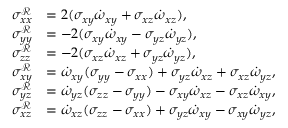Convert formula to latex. <formula><loc_0><loc_0><loc_500><loc_500>\begin{array} { r l } { \sigma _ { x x } ^ { \mathcal { R } } } & { = 2 ( \sigma _ { x y } \dot { \omega } _ { x y } + \sigma _ { x z } \dot { \omega } _ { x z } ) , } \\ { \sigma _ { y y } ^ { \mathcal { R } } } & { = - 2 ( \sigma _ { x y } \dot { \omega } _ { x y } - \sigma _ { y z } \dot { \omega } _ { y z } ) , } \\ { \sigma _ { z z } ^ { \mathcal { R } } } & { = - 2 ( \sigma _ { x z } \dot { \omega } _ { x z } + \sigma _ { y z } \dot { \omega } _ { y z } ) , } \\ { \sigma _ { x y } ^ { \mathcal { R } } } & { = \dot { \omega } _ { x y } ( \sigma _ { y y } - \sigma _ { x x } ) + \sigma _ { y z } \dot { \omega } _ { x z } + \sigma _ { x z } \dot { \omega } _ { y z } , } \\ { \sigma _ { y z } ^ { \mathcal { R } } } & { = \dot { \omega } _ { y z } ( \sigma _ { z z } - \sigma _ { y y } ) - \sigma _ { x y } \dot { \omega } _ { x z } - \sigma _ { x z } \dot { \omega } _ { x y } , } \\ { \sigma _ { x z } ^ { \mathcal { R } } } & { = \dot { \omega } _ { x z } ( \sigma _ { z z } - \sigma _ { x x } ) + \sigma _ { y z } \dot { \omega } _ { x y } - \sigma _ { x y } \dot { \omega } _ { y z } , } \end{array}</formula> 